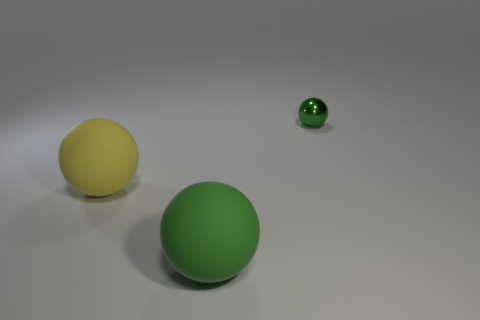Subtract all green shiny spheres. How many spheres are left? 2 Subtract all brown cylinders. How many green balls are left? 2 Subtract 3 spheres. How many spheres are left? 0 Subtract all yellow balls. How many balls are left? 2 Add 2 big spheres. How many objects exist? 5 Subtract all green balls. Subtract all yellow cylinders. How many balls are left? 1 Subtract all yellow things. Subtract all metal things. How many objects are left? 1 Add 2 large matte balls. How many large matte balls are left? 4 Add 1 large objects. How many large objects exist? 3 Subtract 0 blue cubes. How many objects are left? 3 